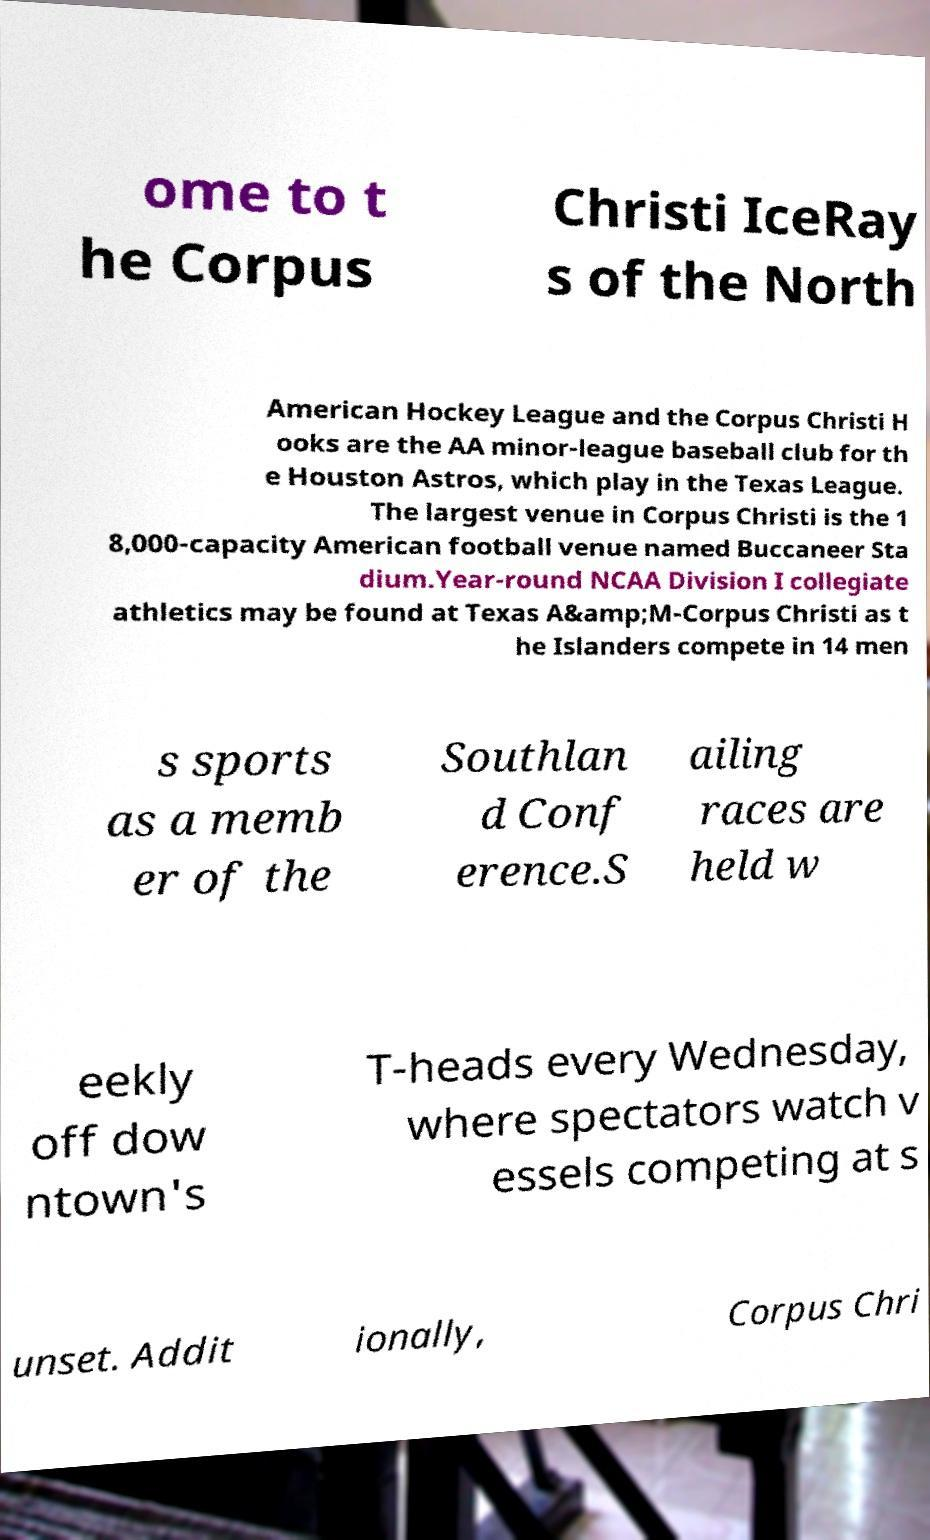Can you read and provide the text displayed in the image?This photo seems to have some interesting text. Can you extract and type it out for me? ome to t he Corpus Christi IceRay s of the North American Hockey League and the Corpus Christi H ooks are the AA minor-league baseball club for th e Houston Astros, which play in the Texas League. The largest venue in Corpus Christi is the 1 8,000-capacity American football venue named Buccaneer Sta dium.Year-round NCAA Division I collegiate athletics may be found at Texas A&amp;M-Corpus Christi as t he Islanders compete in 14 men s sports as a memb er of the Southlan d Conf erence.S ailing races are held w eekly off dow ntown's T-heads every Wednesday, where spectators watch v essels competing at s unset. Addit ionally, Corpus Chri 